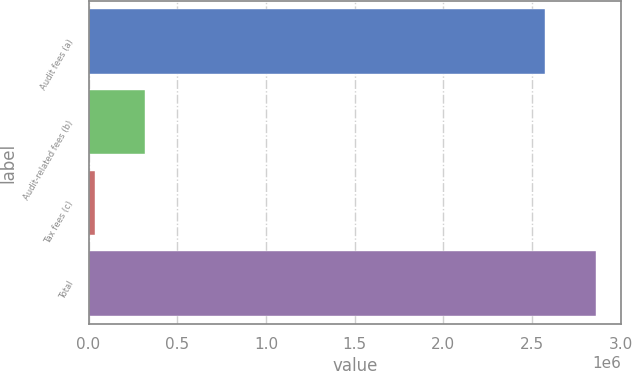<chart> <loc_0><loc_0><loc_500><loc_500><bar_chart><fcel>Audit fees (a)<fcel>Audit-related fees (b)<fcel>Tax fees (c)<fcel>Total<nl><fcel>2.571e+06<fcel>319300<fcel>37000<fcel>2.86e+06<nl></chart> 